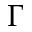Convert formula to latex. <formula><loc_0><loc_0><loc_500><loc_500>\Gamma</formula> 